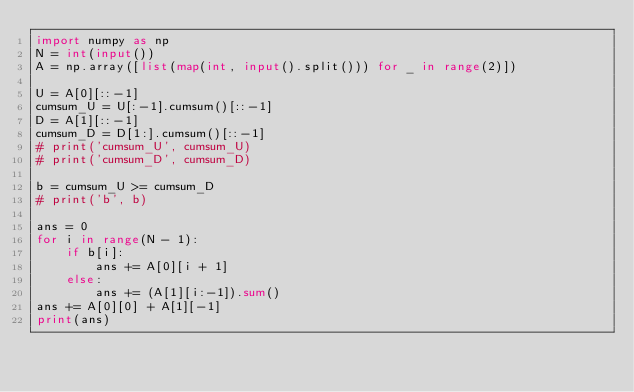<code> <loc_0><loc_0><loc_500><loc_500><_Python_>import numpy as np
N = int(input())
A = np.array([list(map(int, input().split())) for _ in range(2)])

U = A[0][::-1]
cumsum_U = U[:-1].cumsum()[::-1]
D = A[1][::-1]
cumsum_D = D[1:].cumsum()[::-1]
# print('cumsum_U', cumsum_U)
# print('cumsum_D', cumsum_D)

b = cumsum_U >= cumsum_D
# print('b', b)

ans = 0
for i in range(N - 1):
    if b[i]:
        ans += A[0][i + 1]
    else:
        ans += (A[1][i:-1]).sum()
ans += A[0][0] + A[1][-1]
print(ans)
</code> 